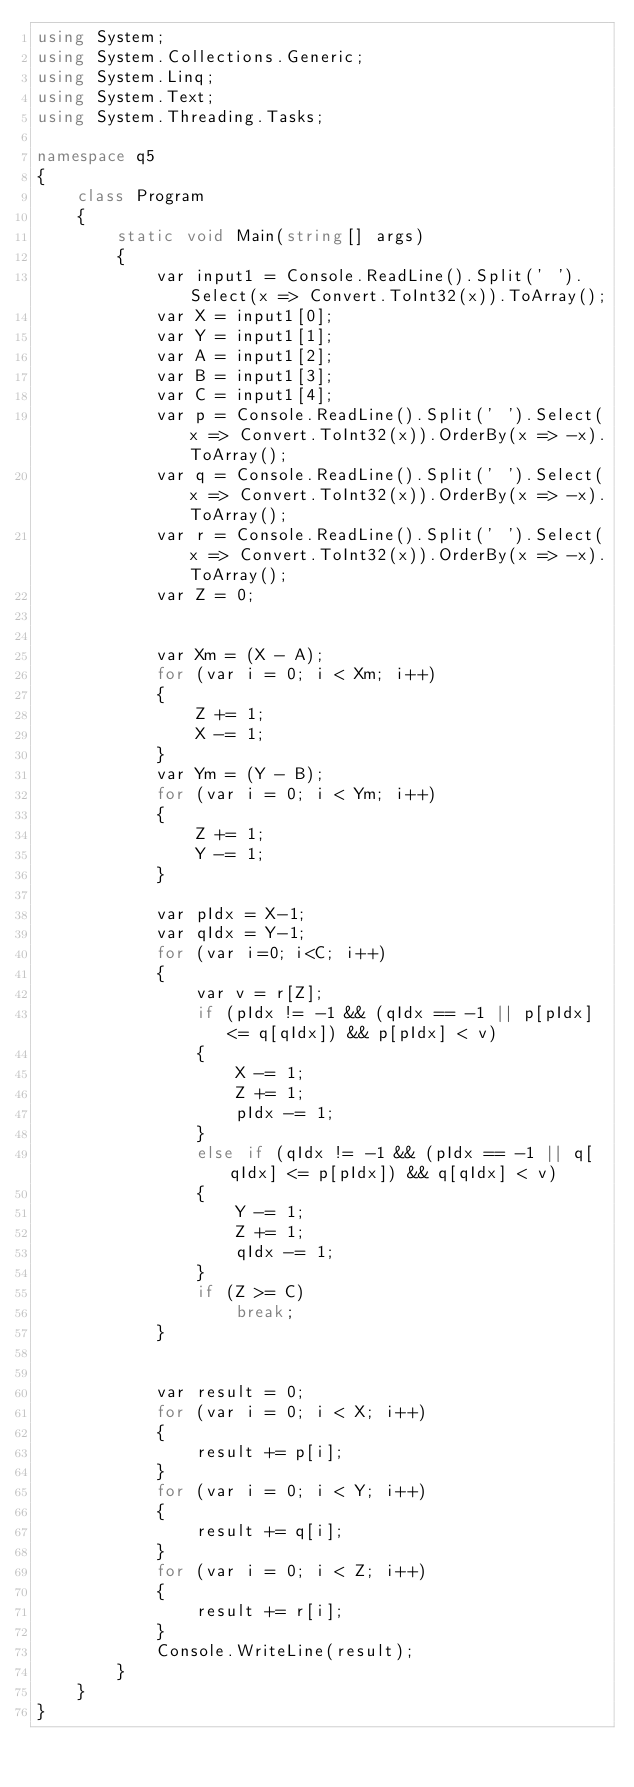<code> <loc_0><loc_0><loc_500><loc_500><_C#_>using System;
using System.Collections.Generic;
using System.Linq;
using System.Text;
using System.Threading.Tasks;

namespace q5
{
    class Program
    {
        static void Main(string[] args)
        {
            var input1 = Console.ReadLine().Split(' ').Select(x => Convert.ToInt32(x)).ToArray();
            var X = input1[0];
            var Y = input1[1];
            var A = input1[2];
            var B = input1[3];
            var C = input1[4];
            var p = Console.ReadLine().Split(' ').Select(x => Convert.ToInt32(x)).OrderBy(x => -x).ToArray();
            var q = Console.ReadLine().Split(' ').Select(x => Convert.ToInt32(x)).OrderBy(x => -x).ToArray();
            var r = Console.ReadLine().Split(' ').Select(x => Convert.ToInt32(x)).OrderBy(x => -x).ToArray();
            var Z = 0;


            var Xm = (X - A);
            for (var i = 0; i < Xm; i++)
            {
                Z += 1;
                X -= 1;
            }
            var Ym = (Y - B);
            for (var i = 0; i < Ym; i++)
            {
                Z += 1;
                Y -= 1;
            }

            var pIdx = X-1;
            var qIdx = Y-1;
            for (var i=0; i<C; i++)
            {
                var v = r[Z];
                if (pIdx != -1 && (qIdx == -1 || p[pIdx] <= q[qIdx]) && p[pIdx] < v)
                {
                    X -= 1;
                    Z += 1;
                    pIdx -= 1;
                }
                else if (qIdx != -1 && (pIdx == -1 || q[qIdx] <= p[pIdx]) && q[qIdx] < v)
                {
                    Y -= 1;
                    Z += 1;
                    qIdx -= 1;
                }
                if (Z >= C)
                    break;
            }


            var result = 0;
            for (var i = 0; i < X; i++)
            {
                result += p[i];
            }
            for (var i = 0; i < Y; i++)
            {
                result += q[i];
            }
            for (var i = 0; i < Z; i++)
            {
                result += r[i];
            }
            Console.WriteLine(result);
        }
    }
}
</code> 